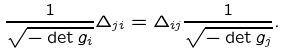Convert formula to latex. <formula><loc_0><loc_0><loc_500><loc_500>\frac { 1 } { \sqrt { - \det g _ { i } } } \Delta _ { j i } = \Delta _ { i j } \frac { 1 } { \sqrt { - \det g _ { j } } } .</formula> 